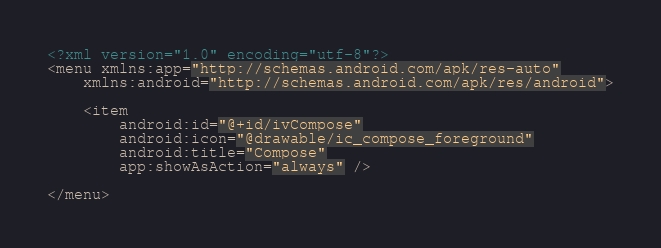Convert code to text. <code><loc_0><loc_0><loc_500><loc_500><_XML_><?xml version="1.0" encoding="utf-8"?>
<menu xmlns:app="http://schemas.android.com/apk/res-auto"
    xmlns:android="http://schemas.android.com/apk/res/android">

    <item
        android:id="@+id/ivCompose"
        android:icon="@drawable/ic_compose_foreground"
        android:title="Compose"
        app:showAsAction="always" />

</menu></code> 